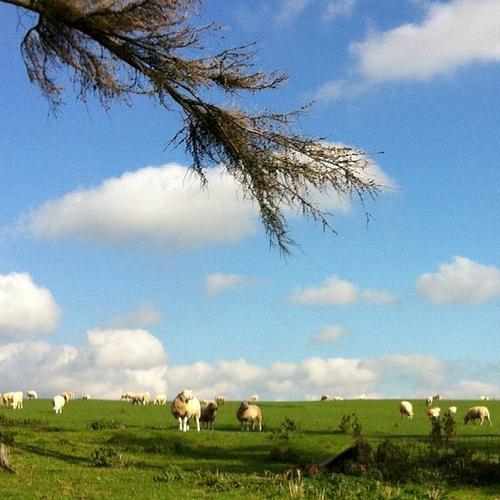How many branches are there?
Give a very brief answer. 1. 